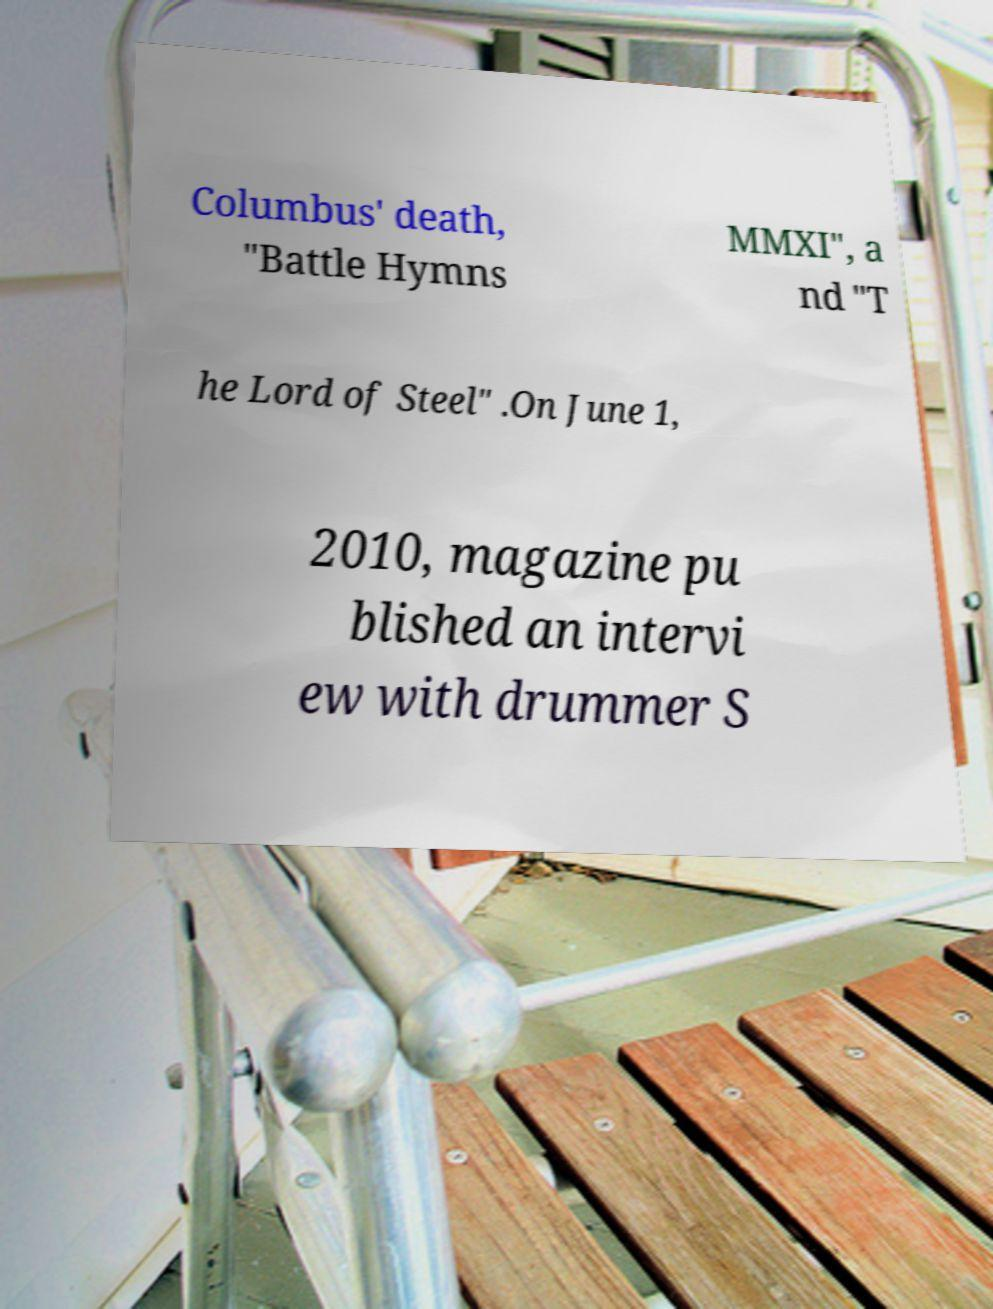For documentation purposes, I need the text within this image transcribed. Could you provide that? Columbus' death, "Battle Hymns MMXI", a nd "T he Lord of Steel" .On June 1, 2010, magazine pu blished an intervi ew with drummer S 